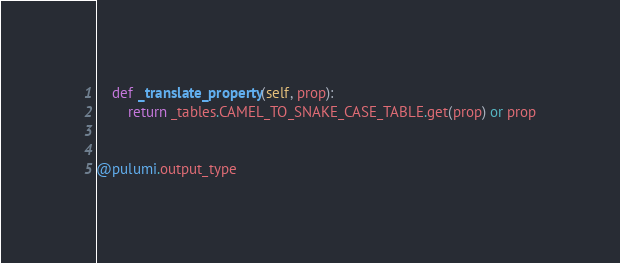<code> <loc_0><loc_0><loc_500><loc_500><_Python_>
    def _translate_property(self, prop):
        return _tables.CAMEL_TO_SNAKE_CASE_TABLE.get(prop) or prop


@pulumi.output_type</code> 